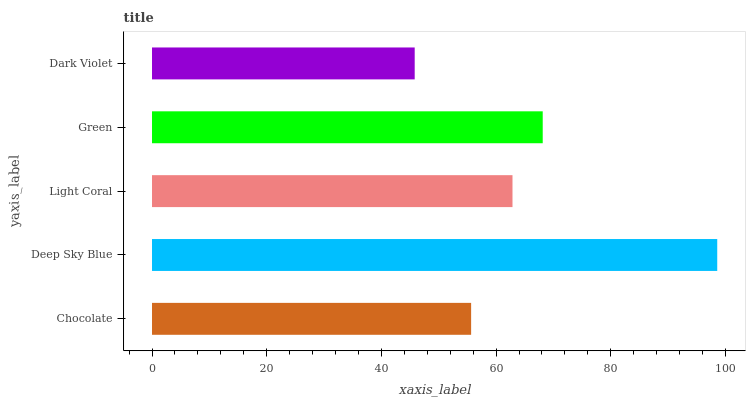Is Dark Violet the minimum?
Answer yes or no. Yes. Is Deep Sky Blue the maximum?
Answer yes or no. Yes. Is Light Coral the minimum?
Answer yes or no. No. Is Light Coral the maximum?
Answer yes or no. No. Is Deep Sky Blue greater than Light Coral?
Answer yes or no. Yes. Is Light Coral less than Deep Sky Blue?
Answer yes or no. Yes. Is Light Coral greater than Deep Sky Blue?
Answer yes or no. No. Is Deep Sky Blue less than Light Coral?
Answer yes or no. No. Is Light Coral the high median?
Answer yes or no. Yes. Is Light Coral the low median?
Answer yes or no. Yes. Is Dark Violet the high median?
Answer yes or no. No. Is Chocolate the low median?
Answer yes or no. No. 